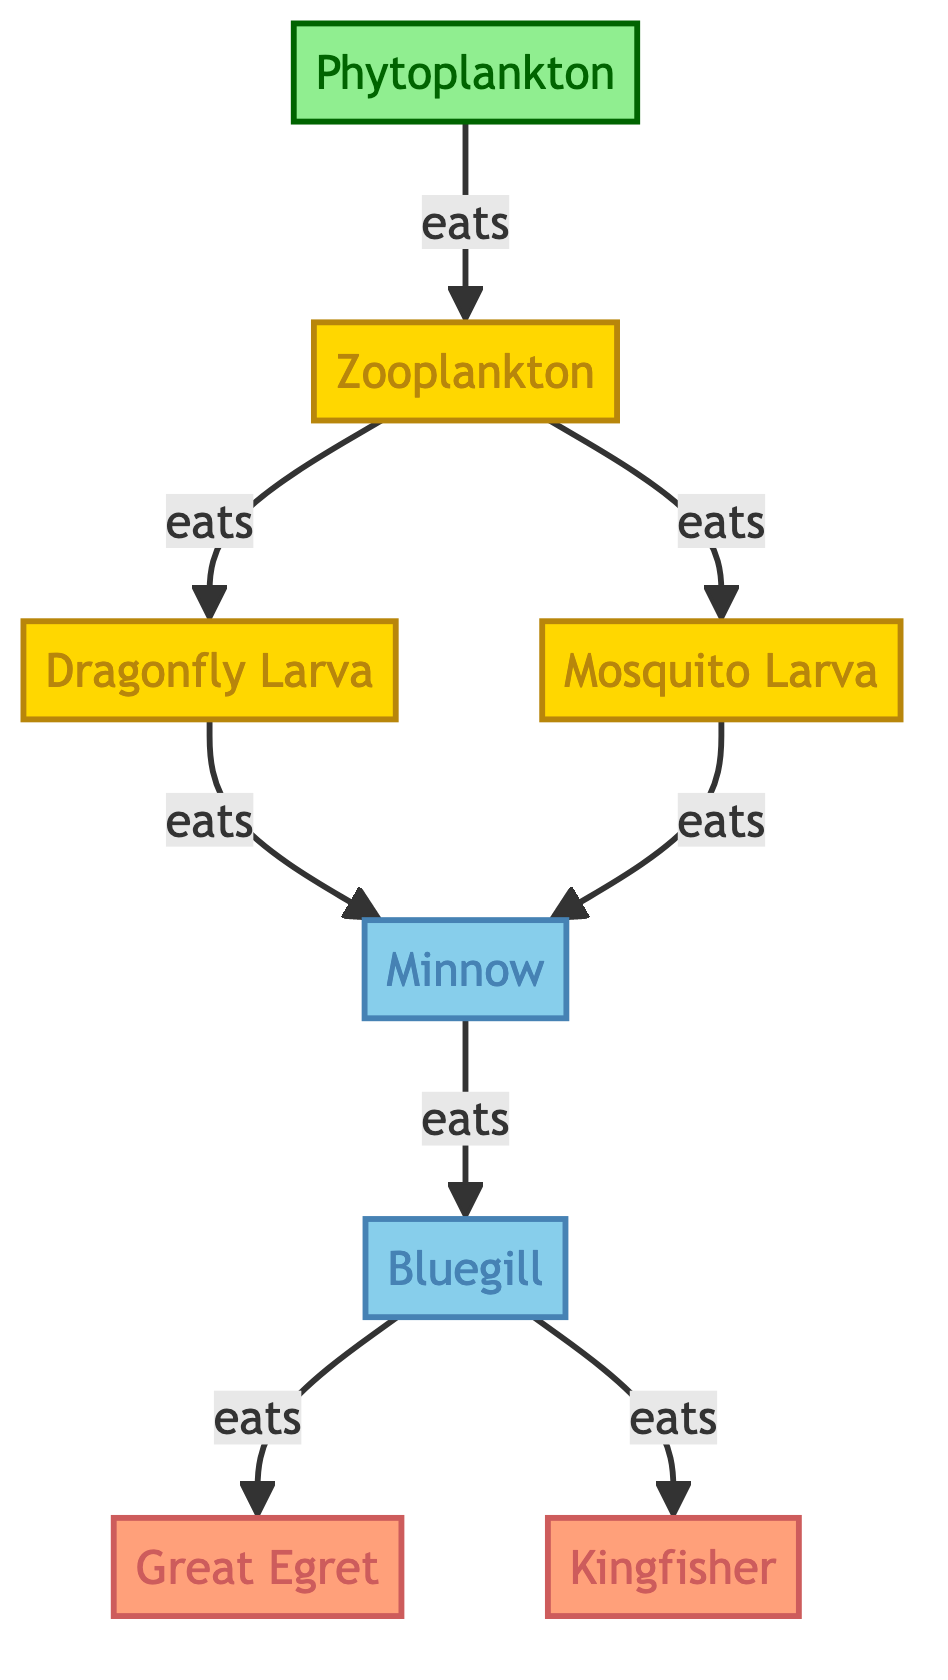What is the primary producer in this food chain? The diagram shows that Phytoplankton, represented as node 1, is the starting point of the food chain and is categorized as algae, which are primary producers.
Answer: Phytoplankton How many different types of insects are represented in the diagram? By examining the diagram, there are three types of insects listed: Zooplankton, Dragonfly Larva, and Mosquito Larva (nodes 2, 3, and 4 respectively), so we count three.
Answer: 3 Which fish can be eaten by the Great Egret? According to the diagram, the Great Egret (node 7) can eat Bluegill (node 6) as it is linked directly to it in the flow of consumption.
Answer: Bluegill What type of organism directly consumes the Zooplankton? The diagram indicates that both the Dragonfly Larva and the Mosquito Larva consume Zooplankton (node 2) as they are both shown as direct links from Zooplankton.
Answer: Dragonfly Larva and Mosquito Larva How many edges are there in total in this food chain? To find the total edges, we count the number of directed arrows in the diagram. There are a total of six directed arrows connecting various organisms which represent the eating relationships.
Answer: 6 What is the last organism in the food chain? The diagram shows that the Bluegill (node 6) is consumed by both the Great Egret and Kingfisher (nodes 7 and 8), making it the last organism in terms of who is eaten in this specific chain of consumption.
Answer: Bluegill Which insect is the top predator in this food chain? By reviewing the links in the diagram, the Dragonfly Larva (node 3) and Mosquito Larva (node 4) both eat fish, but since it is specifically a food chain diagram, we generally refer to the Bluegill as technically being consumed before reaching the birds. Therefore, the Dragonfly Larva is the only insect that consumes smaller insects before fish.
Answer: Dragonfly Larva Which birds are at the top of this food chain? The diagram concludes with two birds, the Great Egret and the Kingfisher (nodes 7 and 8), which are both at the top of the food chain as the final consumers of fish.
Answer: Great Egret and Kingfisher 